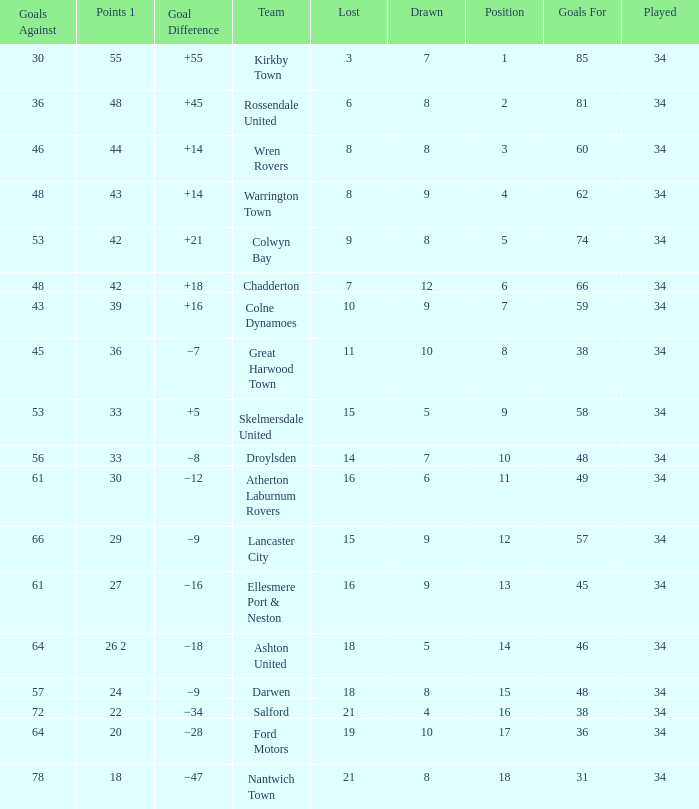What is the total number of goals for when the drawn is less than 7, less than 21 games have been lost, and there are 1 of 33 points? 1.0. 